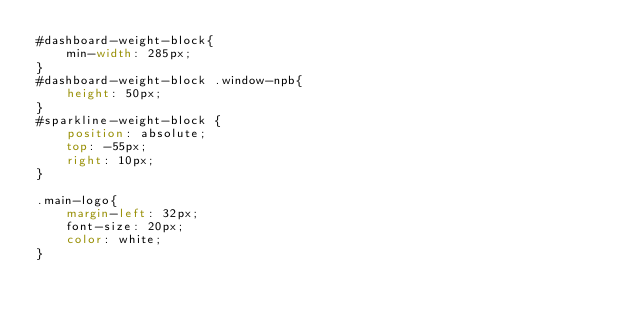Convert code to text. <code><loc_0><loc_0><loc_500><loc_500><_CSS_>#dashboard-weight-block{
    min-width: 285px;
}
#dashboard-weight-block .window-npb{
    height: 50px;
}
#sparkline-weight-block {
    position: absolute;
    top: -55px;
    right: 10px;
}

.main-logo{
    margin-left: 32px;
    font-size: 20px;
    color: white;
}</code> 